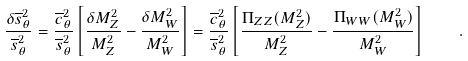<formula> <loc_0><loc_0><loc_500><loc_500>\frac { \delta \overline { s } _ { \theta } ^ { 2 } } { \overline { s } _ { \theta } ^ { 2 } } = \frac { \overline { c } _ { \theta } ^ { 2 } } { \overline { s } _ { \theta } ^ { 2 } } \left [ \frac { \delta M _ { Z } ^ { 2 } } { M _ { Z } ^ { 2 } } - \frac { \delta M _ { W } ^ { 2 } } { M _ { W } ^ { 2 } } \right ] = \frac { \overline { c } _ { \theta } ^ { 2 } } { \overline { s } _ { \theta } ^ { 2 } } \left [ \frac { \Pi _ { Z Z } ( M _ { Z } ^ { 2 } ) } { M _ { Z } ^ { 2 } } - \frac { \Pi _ { W W } ( M _ { W } ^ { 2 } ) } { M _ { W } ^ { 2 } } \right ] \quad .</formula> 